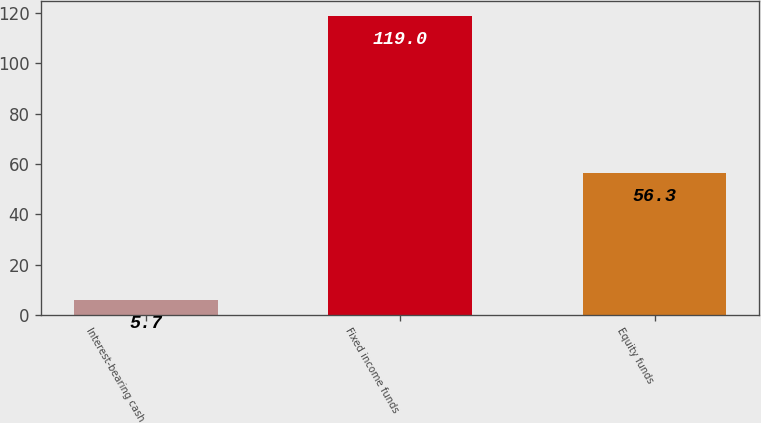<chart> <loc_0><loc_0><loc_500><loc_500><bar_chart><fcel>Interest-bearing cash<fcel>Fixed income funds<fcel>Equity funds<nl><fcel>5.7<fcel>119<fcel>56.3<nl></chart> 